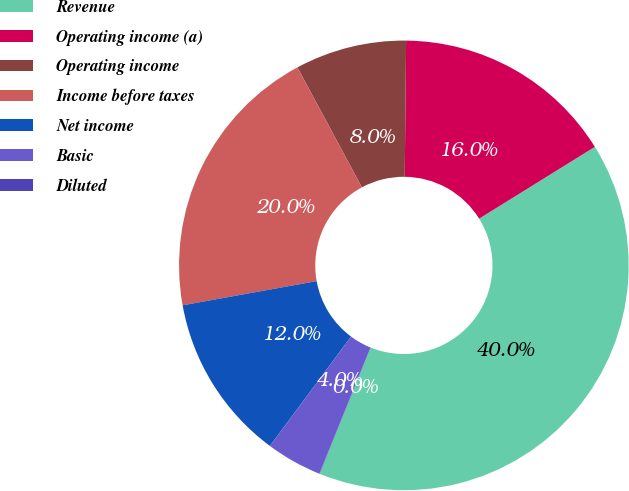Convert chart. <chart><loc_0><loc_0><loc_500><loc_500><pie_chart><fcel>Revenue<fcel>Operating income (a)<fcel>Operating income<fcel>Income before taxes<fcel>Net income<fcel>Basic<fcel>Diluted<nl><fcel>39.95%<fcel>16.0%<fcel>8.01%<fcel>19.99%<fcel>12.0%<fcel>4.02%<fcel>0.03%<nl></chart> 